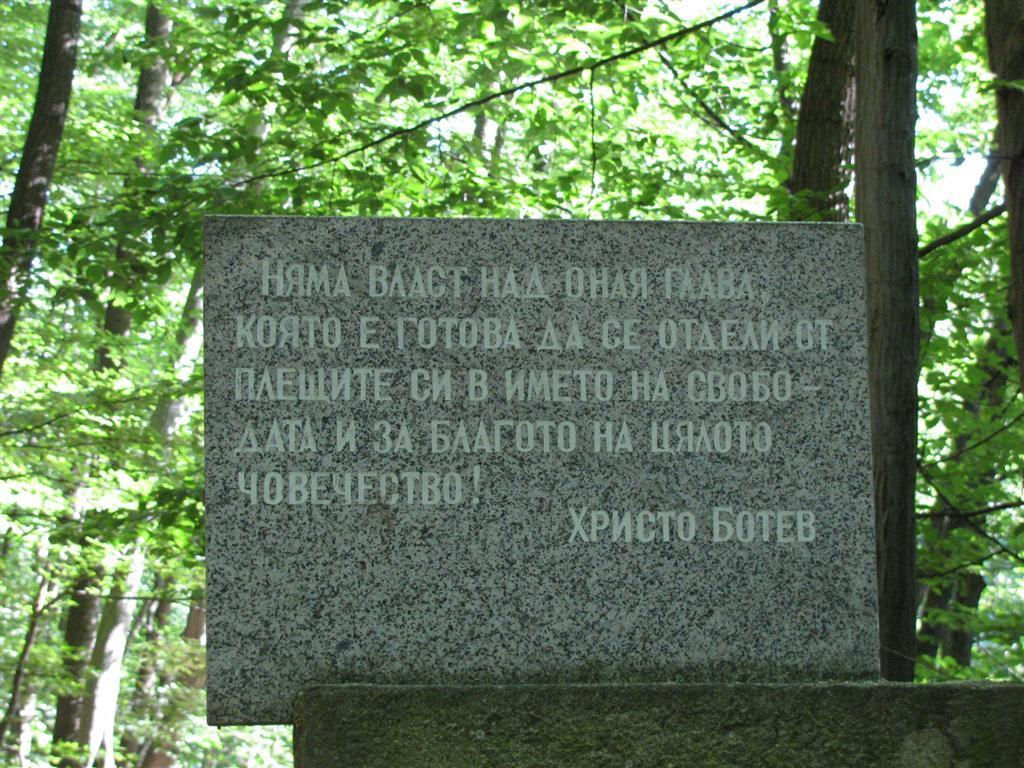What is written on the stone in the foreground of the image? There is text on a stone in the foreground of the image. What can be seen in the background of the image? There are trees in the background of the image. Can you see any airplanes flying over the trees in the background of the image? There is no mention of an airplane in the image, so it cannot be determined if one is flying over the trees. Are there any fairies visible in the image? There is no mention of fairies in the image, so it cannot be determined if any are present. 